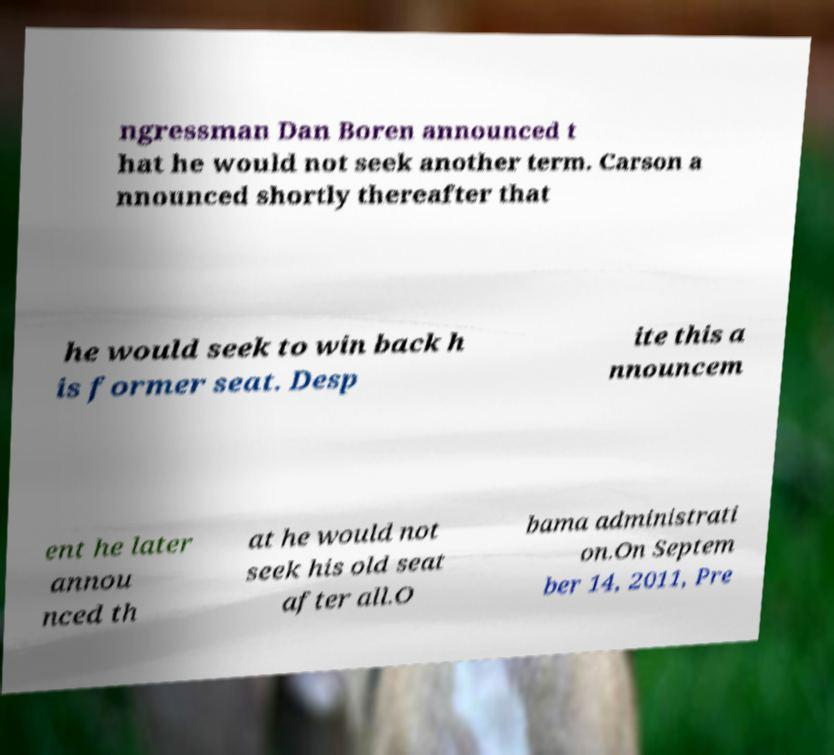Could you extract and type out the text from this image? ngressman Dan Boren announced t hat he would not seek another term. Carson a nnounced shortly thereafter that he would seek to win back h is former seat. Desp ite this a nnouncem ent he later annou nced th at he would not seek his old seat after all.O bama administrati on.On Septem ber 14, 2011, Pre 